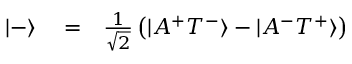<formula> <loc_0><loc_0><loc_500><loc_500>\begin{array} { r l r } { | - \rangle } & = } & { \frac { 1 } { \sqrt { 2 } } \left ( | A ^ { + } T ^ { - } \rangle - | A ^ { - } T ^ { + } \rangle \right ) } \end{array}</formula> 